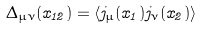<formula> <loc_0><loc_0><loc_500><loc_500>\Delta _ { \mu \nu } ( x _ { 1 2 } ) = \langle j _ { \mu } ( x _ { 1 } ) j _ { \nu } ( x _ { 2 } ) \rangle</formula> 